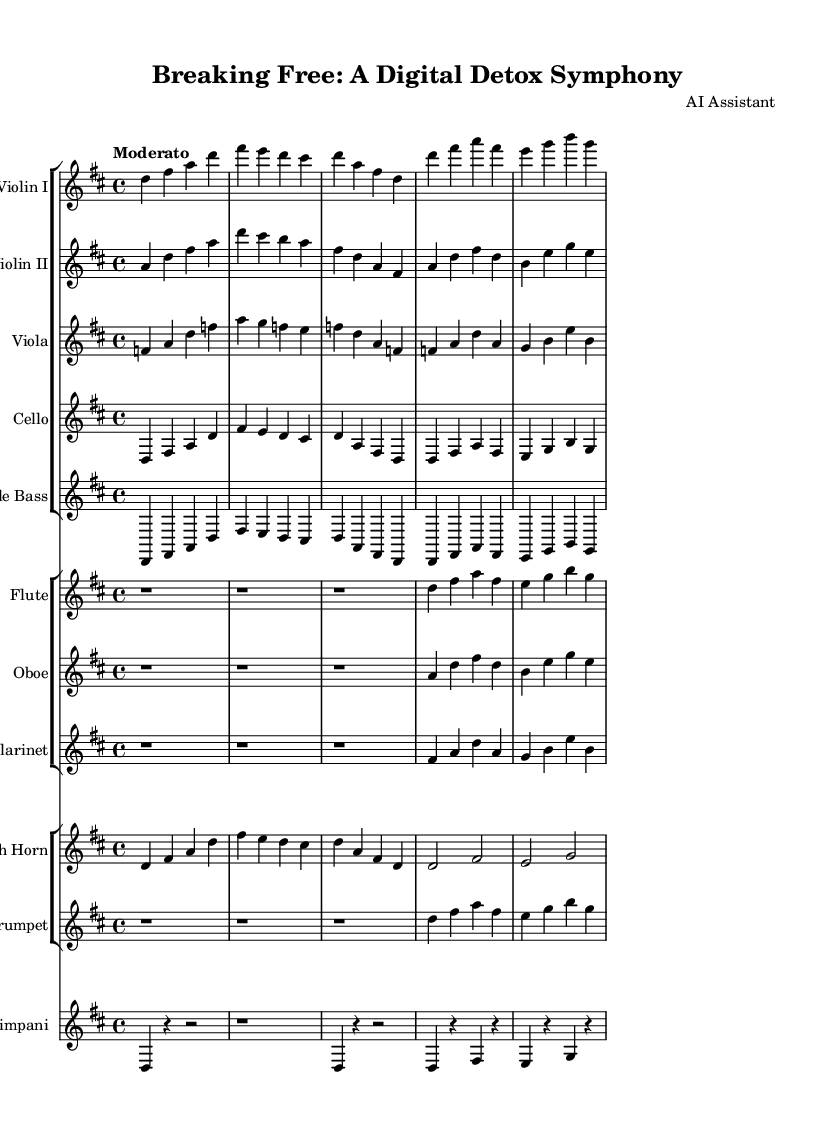What is the key signature of this symphony? The key signature is D major, indicated by two sharps (F# and C#) in the music sheet.
Answer: D major What is the time signature of this symphony? The time signature is 4/4, shown at the beginning of the sheet music, which means there are four beats in each measure.
Answer: 4/4 What is the tempo marking for this symphony? The tempo marking is "Moderato," which suggests a moderate speed for performing the piece.
Answer: Moderato How many different instruments are present in this symphony? There are eight different instruments represented in the sheet music, including strings and woodwinds.
Answer: Eight Which instruments play the introduction section? The introduction section features the Violin I, Violin II, Viola, Cello, Double Bass, Flute, Oboe, Clarinet, French Horn, Trumpet, and Timpani.
Answer: All instruments What is the theme used in the first theme A of this symphony? The first theme A includes the notes played by the strings and woodwinds, forming a cohesive melodic idea throughout different instruments.
Answer: D-F#-A-F# Are there any rest measures in the symphony? Yes, the flute, oboe, and clarinet sections have several measures of rest at the beginning, indicating silence before they join the theme.
Answer: Yes 